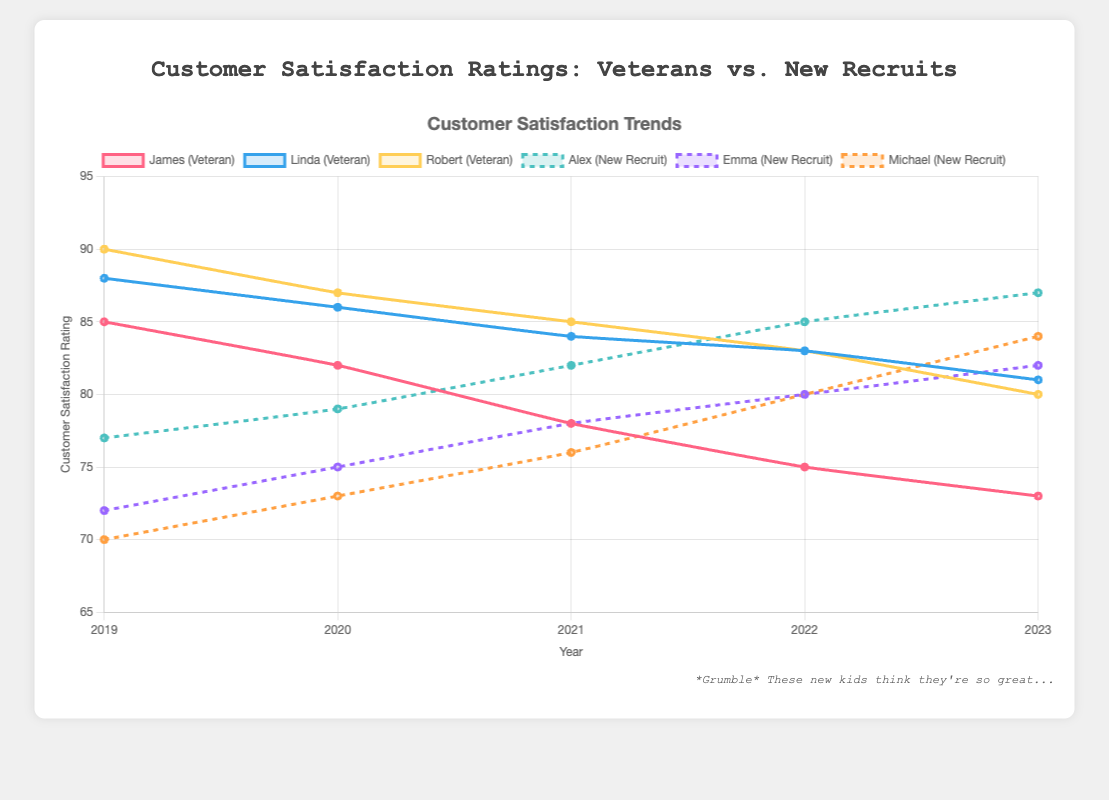How did Linda's customer satisfaction rating change from 2019 to 2023? Linda's customer satisfaction rating started at 88 in 2019 and dropped to 81 in 2023.
Answer: It decreased by 7 points Compare the average customer satisfaction ratings of veteran mechanics in 2021 and 2023. For 2021, the average is (78 + 84 + 85)/3 = 82.3. For 2023, the average is (73 + 81 + 80)/3 = 78.
Answer: 82.3 in 2021 and 78 in 2023 Who had the largest increase in customer satisfaction ratings among the new recruits from 2019 to 2023? Among the new recruits, Michael had the largest increase, starting at 70 in 2019 and rising to 84 in 2023, an increase of 14 points.
Answer: Michael What's the difference between Robert's and Alex's customer satisfaction ratings in 2023? Robert's rating in 2023 is 80, while Alex's rating is 87. The difference is 87 - 80 = 7.
Answer: 7 Which mechanic had the lowest customer satisfaction rating in 2021? Michael had the lowest rating in 2021 with a score of 76.
Answer: Michael How did the average customer satisfaction rating for new recruits change from 2019 to 2023? In 2019, the average rating for new recruits was (77 + 72 + 70)/3 = 73. In 2023, the average rating was (87 + 82 + 84)/3 = 84.3. The change is 84.3 - 73 = 11.3.
Answer: It increased by 11.3 Compare the customer satisfaction rating trends of Linda and Emma. Linda's ratings decreased from 88 to 81 over the five years, while Emma's ratings increased from 72 to 82. Linda's trend is downward, while Emma's trend is upward.
Answer: Linda's trend is downward, Emma's trend is upward What is the color of the line representing James? The line representing James is red.
Answer: Red Which veteran mechanic had the smallest overall decrease in customer satisfaction rating from 2019 to 2023? Linda had the smallest decrease, from 88 in 2019 to 81 in 2023, a decrease of 7 points.
Answer: Linda 